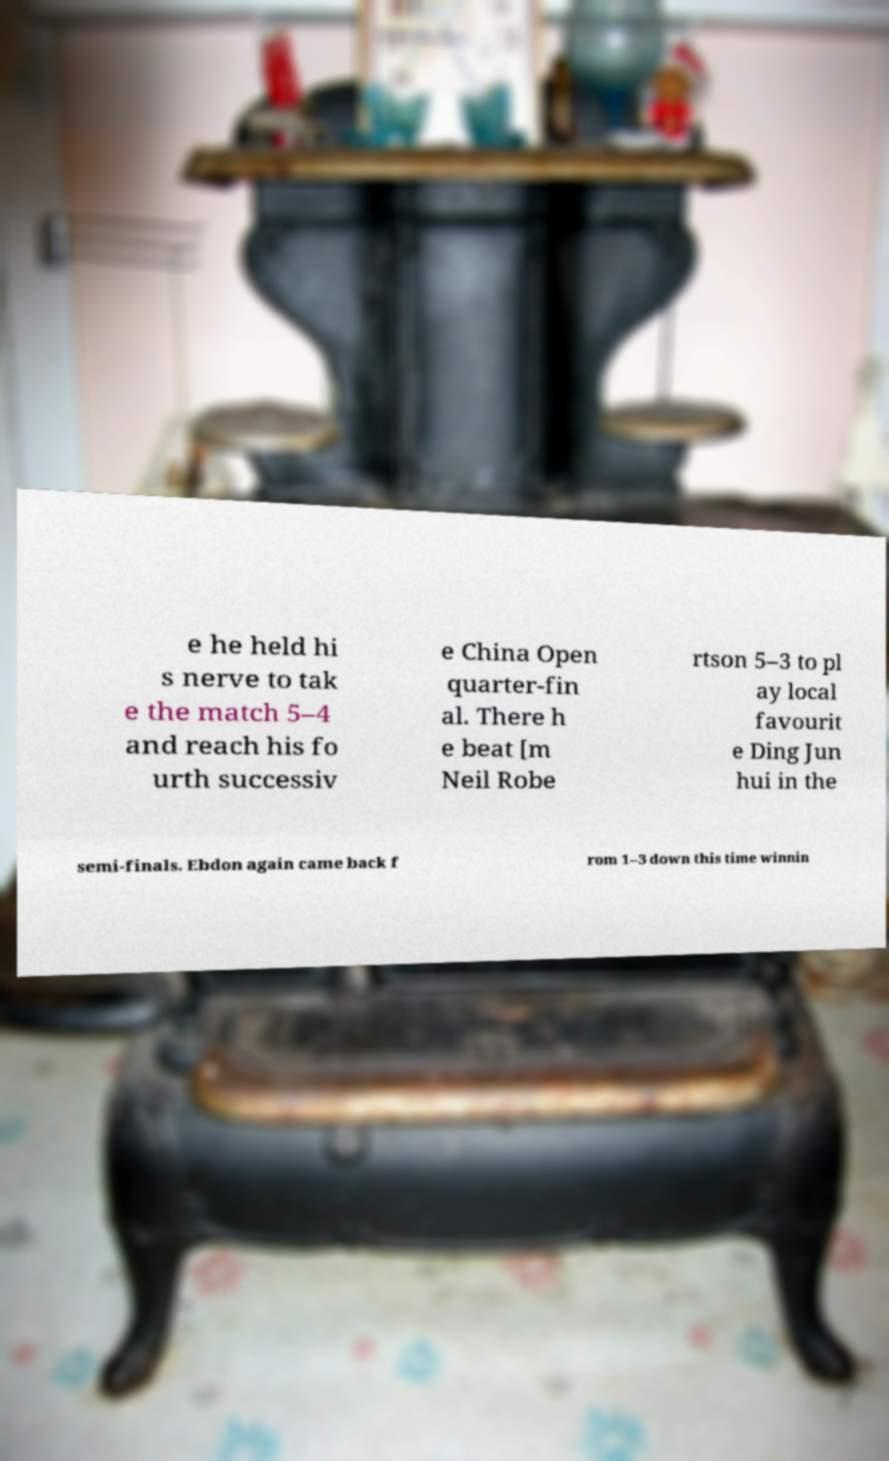I need the written content from this picture converted into text. Can you do that? e he held hi s nerve to tak e the match 5–4 and reach his fo urth successiv e China Open quarter-fin al. There h e beat [m Neil Robe rtson 5–3 to pl ay local favourit e Ding Jun hui in the semi-finals. Ebdon again came back f rom 1–3 down this time winnin 